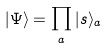<formula> <loc_0><loc_0><loc_500><loc_500>| \Psi \rangle = \prod _ { a } | s \rangle _ { a }</formula> 